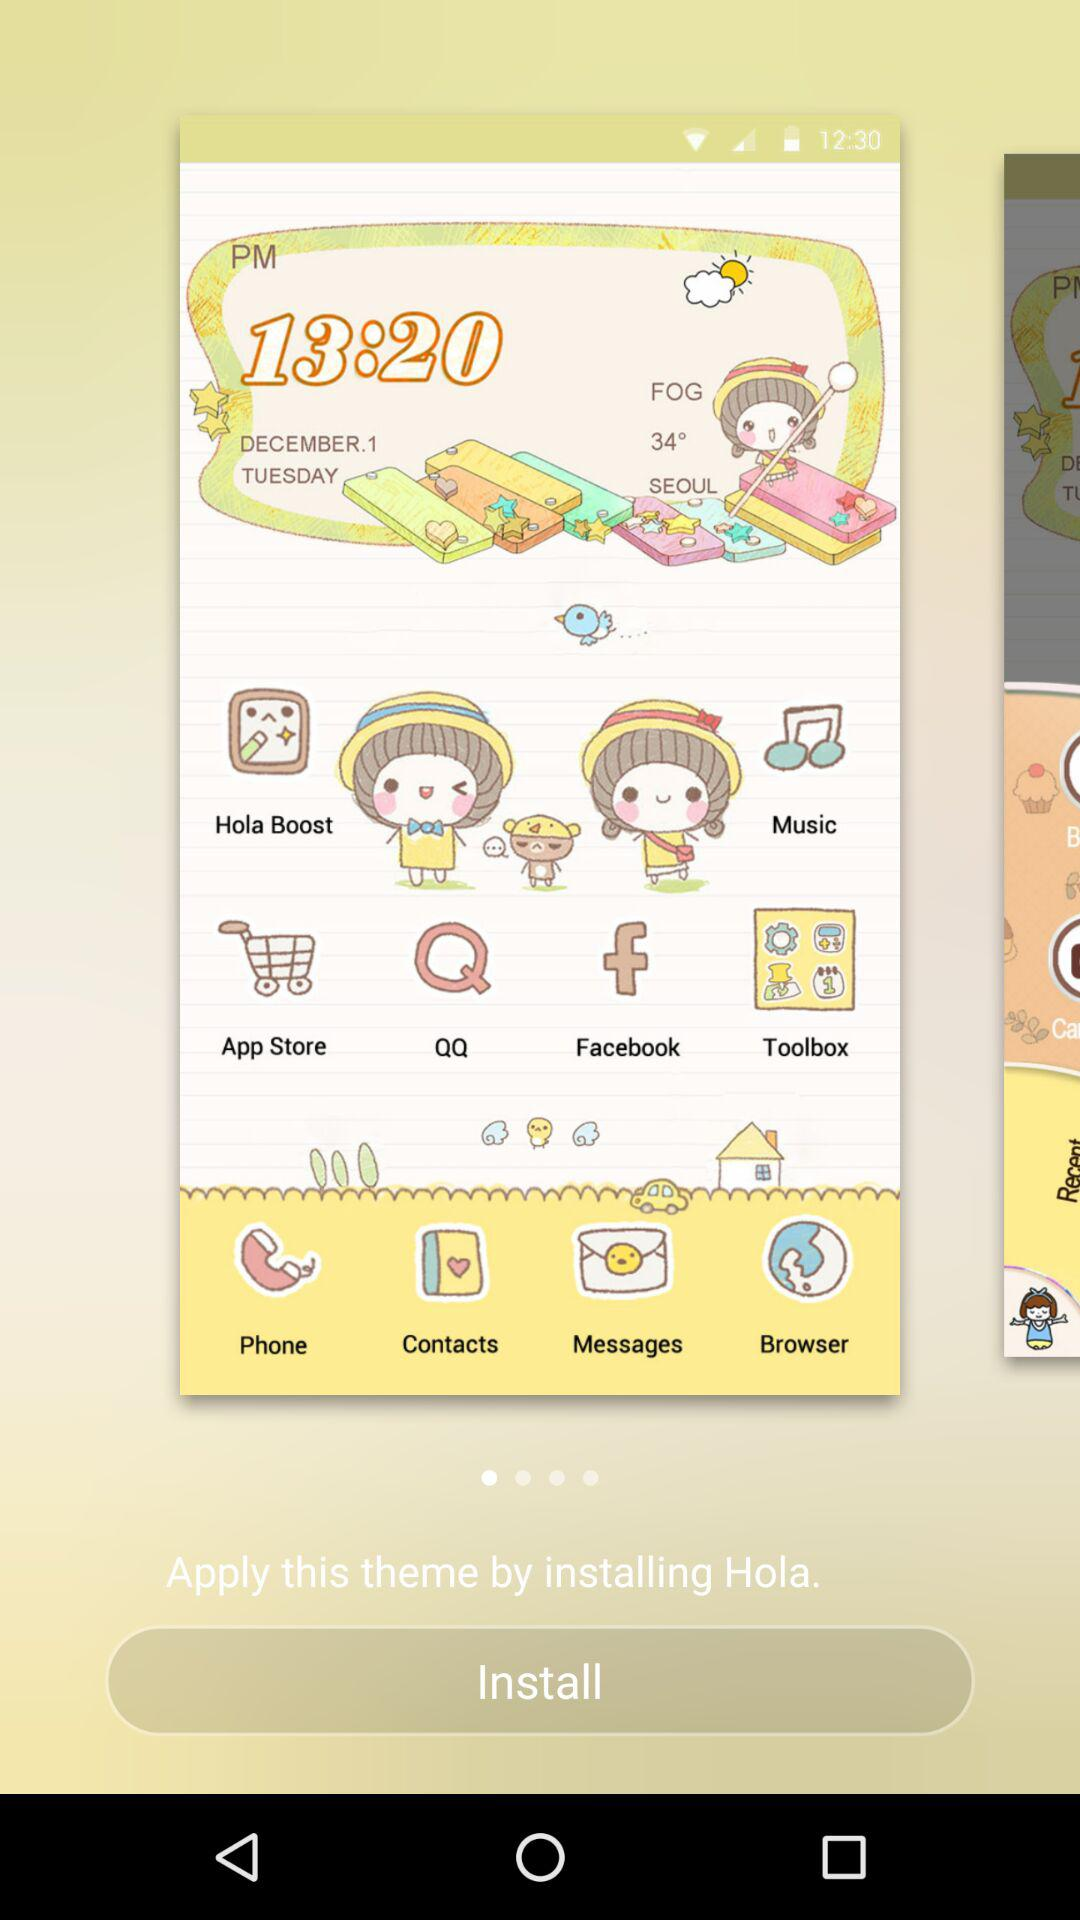What is the given date? The given date is Tuesday, December 1. 